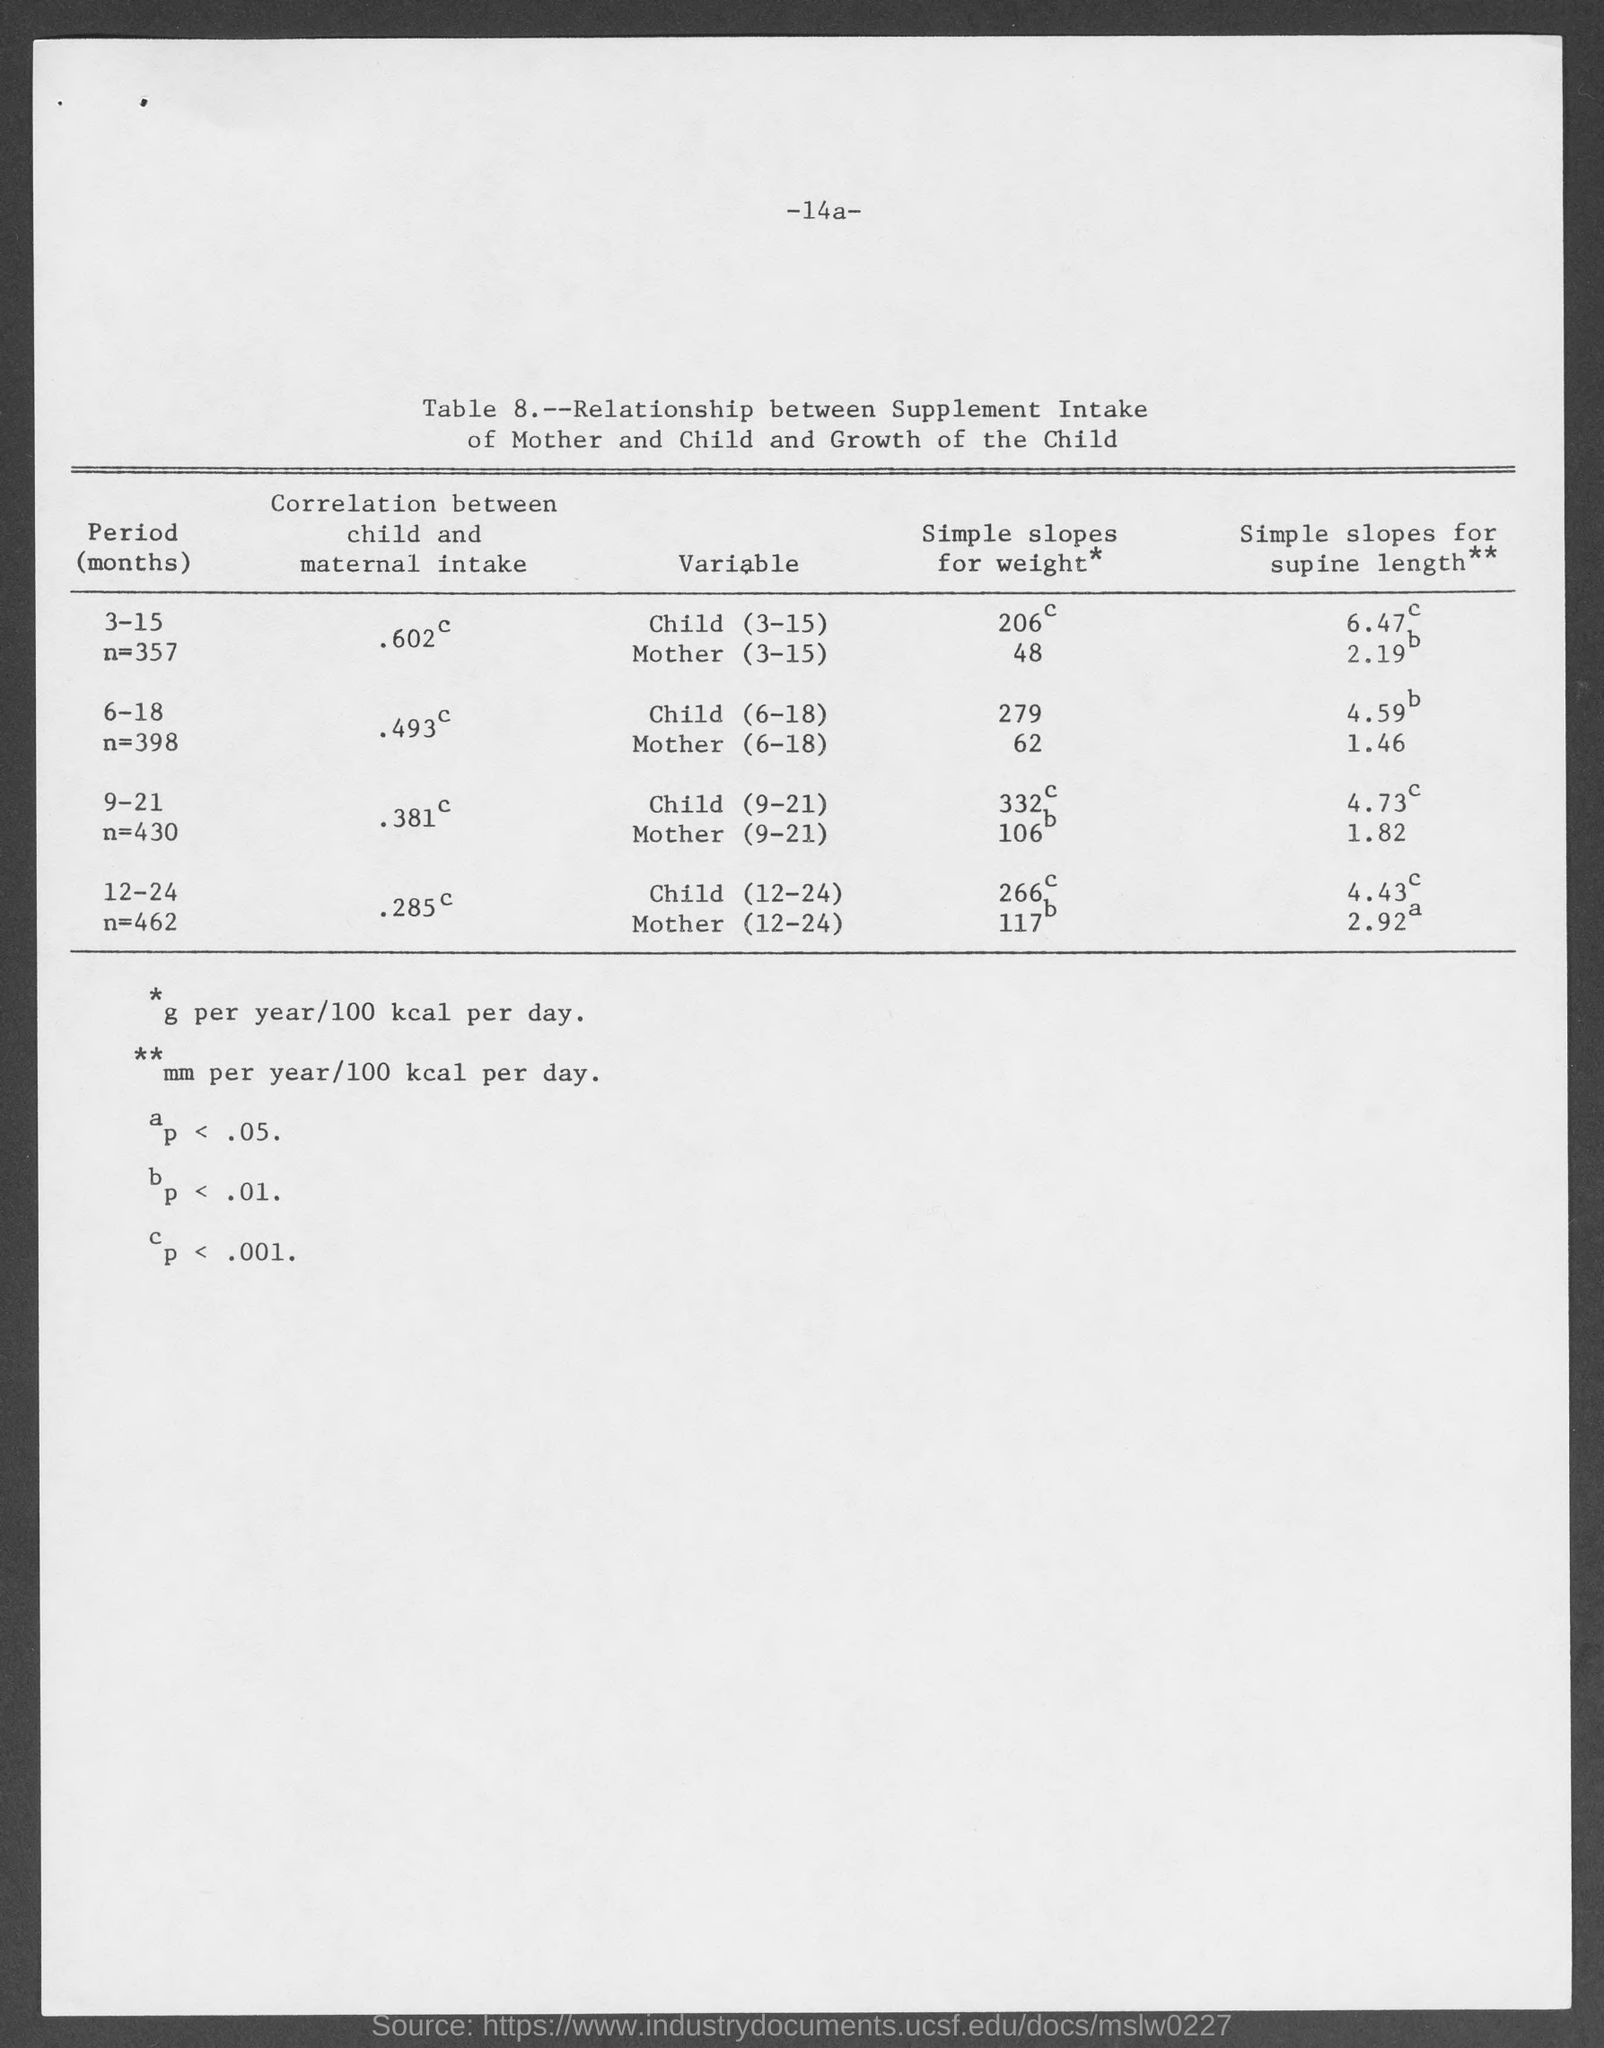What is the table no.?
Offer a very short reply. 8. 